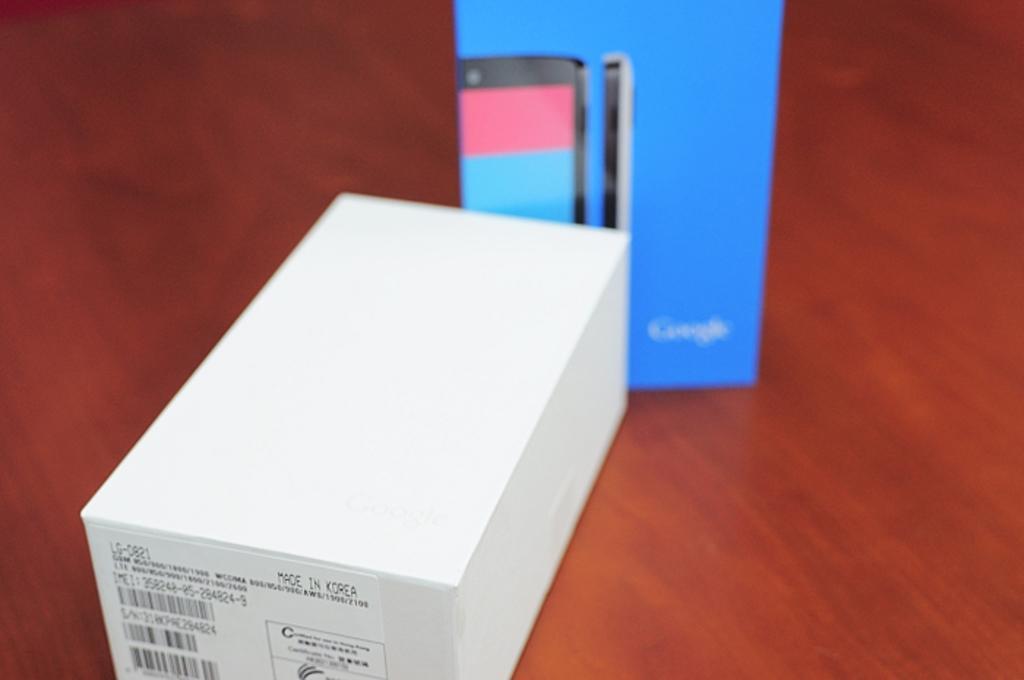<image>
Render a clear and concise summary of the photo. A box that says made in China is in front of a google box. 